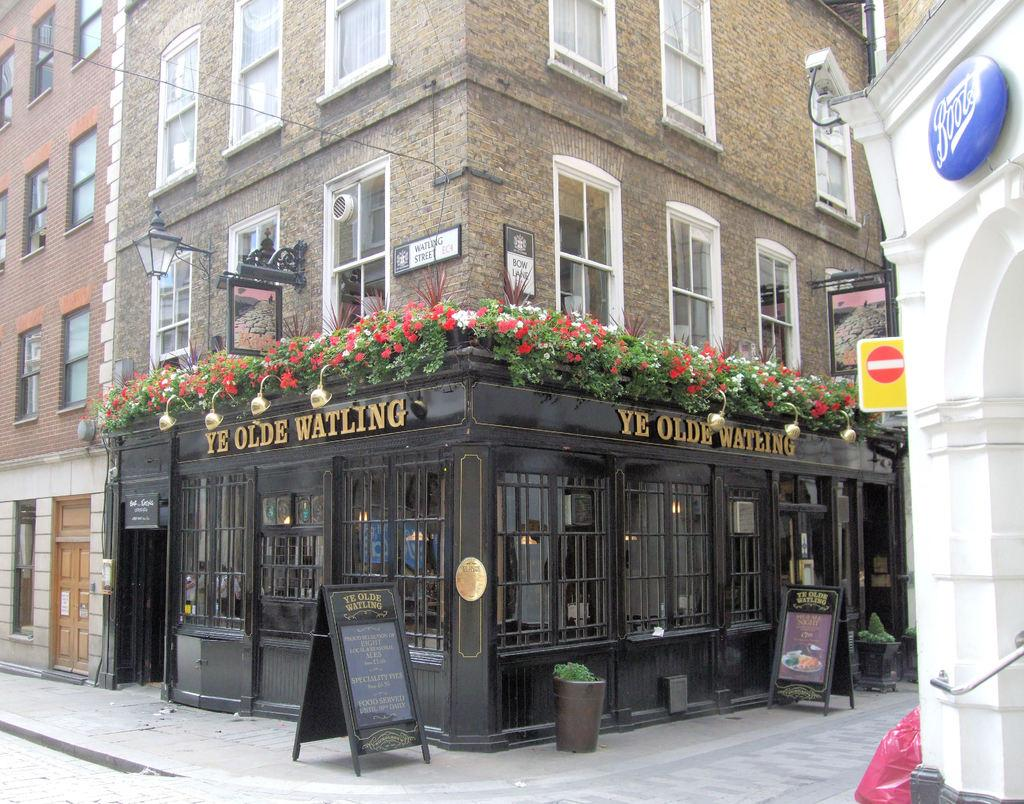What type of buildings are shown in the image? The buildings in the image have glass windows. What can be found at the bottom of these buildings? The buildings have shops at the bottom. What is hanging in front of the shops? Banners are present in front of the shops. What color is the wall on the right side of the image? The wall on the right side of the image is white. What type of toys can be seen on the quince in the image? There is no quince or toys present in the image. How many pizzas are being served in the image? There are no pizzas visible in the image. 